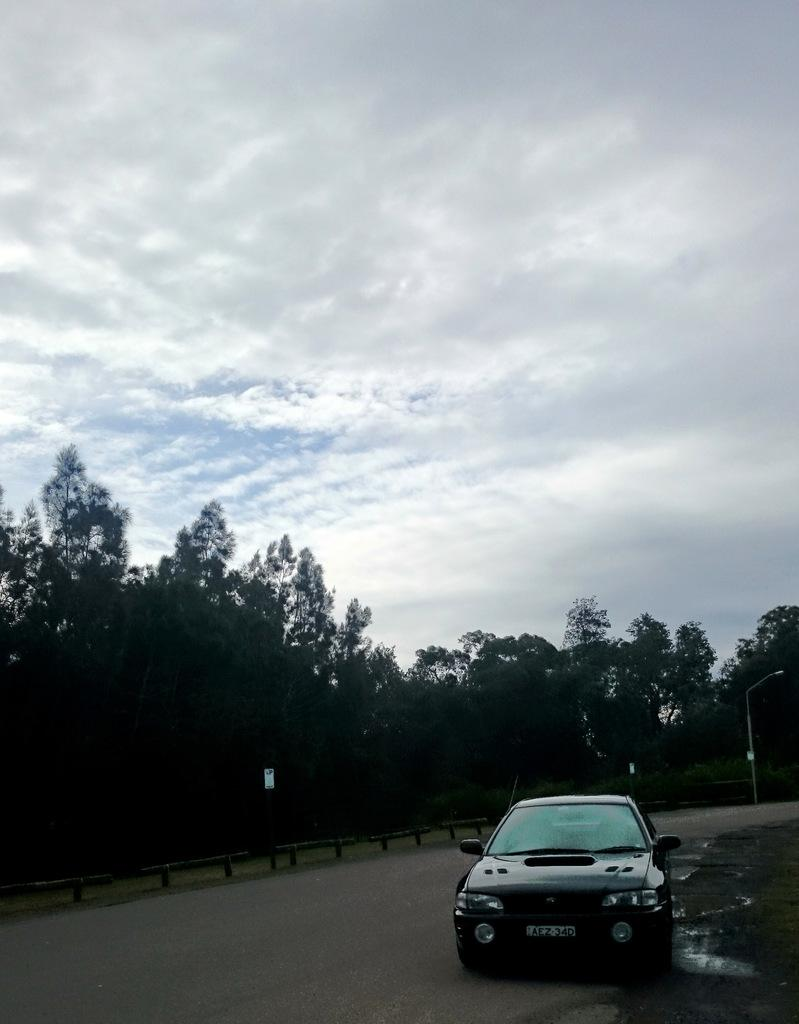What is on the road in the image? There is a car on the road in the image. What can be seen in the background of the image? Boards, a light on a pole, trees, and the sky with clouds are visible in the background. Can you describe the light in the background? There is a light on a pole in the background. What type of vegetation is present in the background? Trees are present in the background. What type of pencil can be seen being used to draw a joke on the car in the image? There is no pencil or joke present in the image; it only features a car on the road and various elements in the background. 